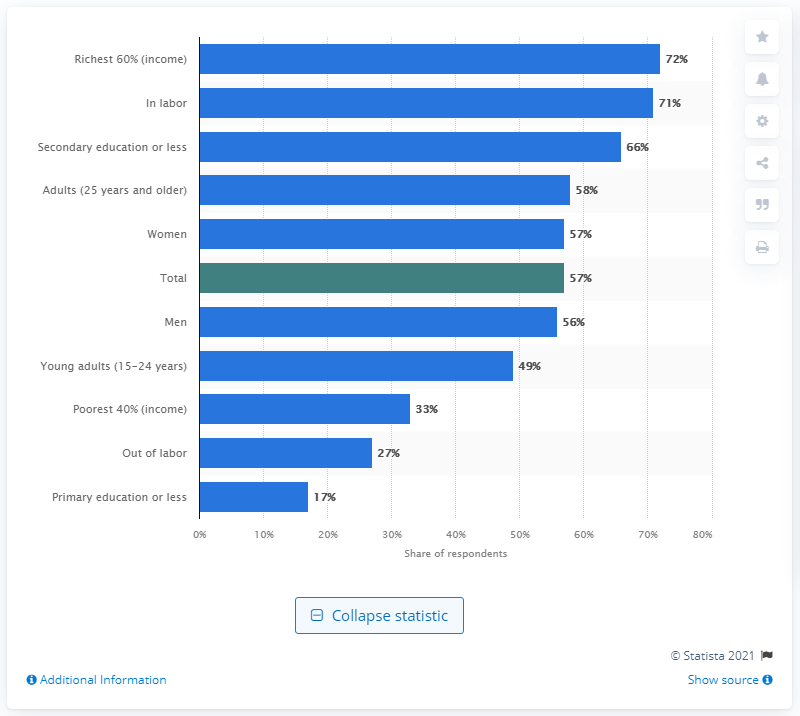Identify some key points in this picture. Seventy-two percent of people reported using the internet to pay bills or purchase items online within the past year. 